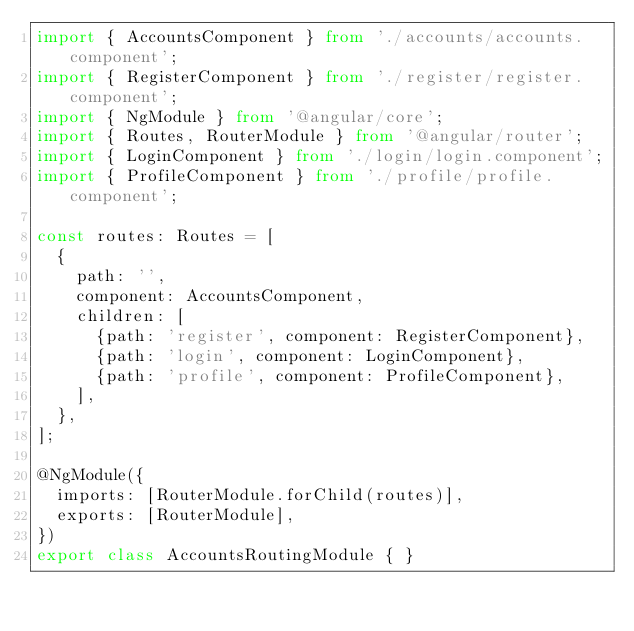Convert code to text. <code><loc_0><loc_0><loc_500><loc_500><_TypeScript_>import { AccountsComponent } from './accounts/accounts.component';
import { RegisterComponent } from './register/register.component';
import { NgModule } from '@angular/core';
import { Routes, RouterModule } from '@angular/router';
import { LoginComponent } from './login/login.component';
import { ProfileComponent } from './profile/profile.component';

const routes: Routes = [
  {
    path: '',
    component: AccountsComponent,
    children: [
      {path: 'register', component: RegisterComponent},
      {path: 'login', component: LoginComponent},
      {path: 'profile', component: ProfileComponent},
    ],
  },
];

@NgModule({
  imports: [RouterModule.forChild(routes)],
  exports: [RouterModule],
})
export class AccountsRoutingModule { }
</code> 